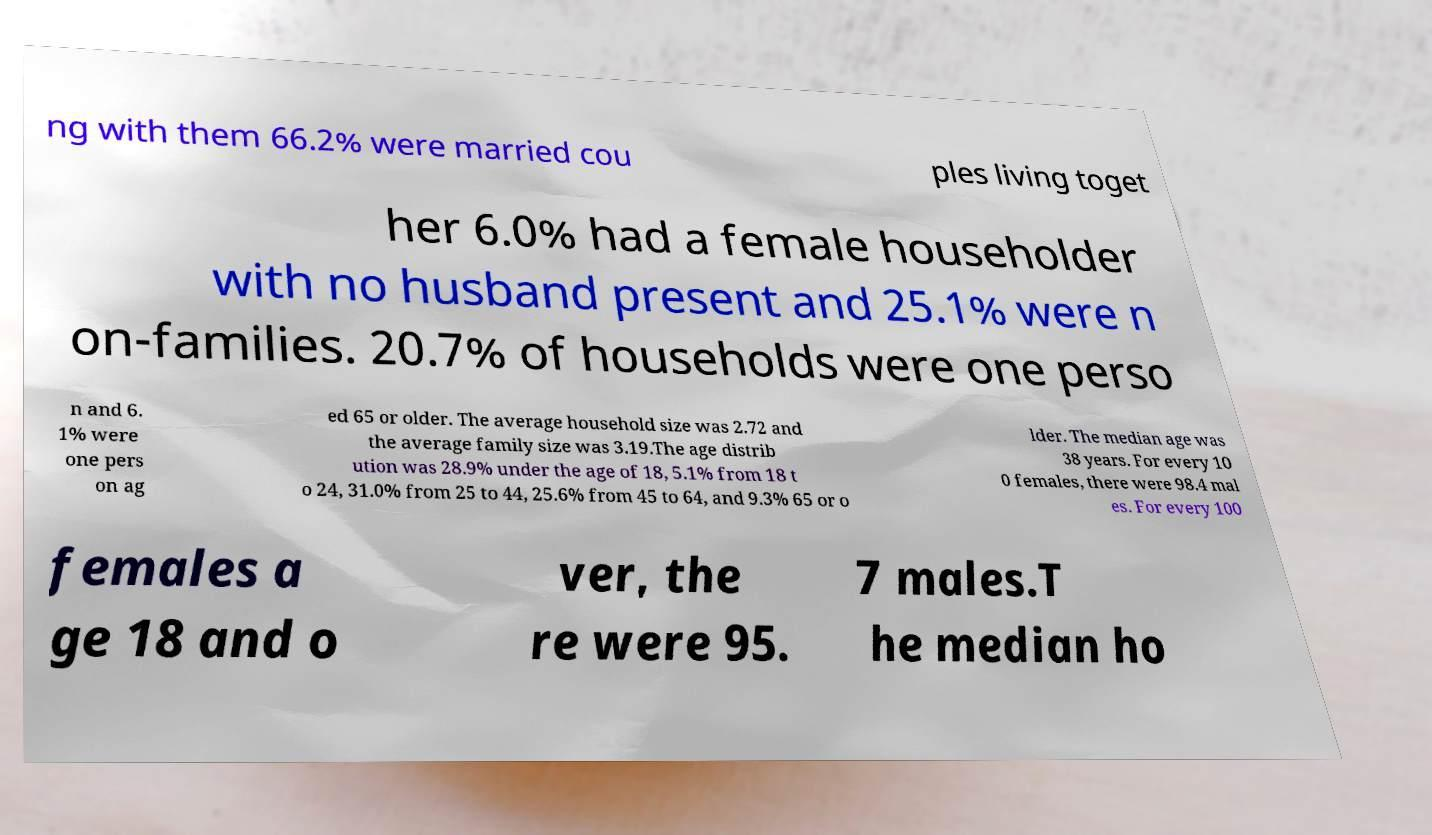For documentation purposes, I need the text within this image transcribed. Could you provide that? ng with them 66.2% were married cou ples living toget her 6.0% had a female householder with no husband present and 25.1% were n on-families. 20.7% of households were one perso n and 6. 1% were one pers on ag ed 65 or older. The average household size was 2.72 and the average family size was 3.19.The age distrib ution was 28.9% under the age of 18, 5.1% from 18 t o 24, 31.0% from 25 to 44, 25.6% from 45 to 64, and 9.3% 65 or o lder. The median age was 38 years. For every 10 0 females, there were 98.4 mal es. For every 100 females a ge 18 and o ver, the re were 95. 7 males.T he median ho 